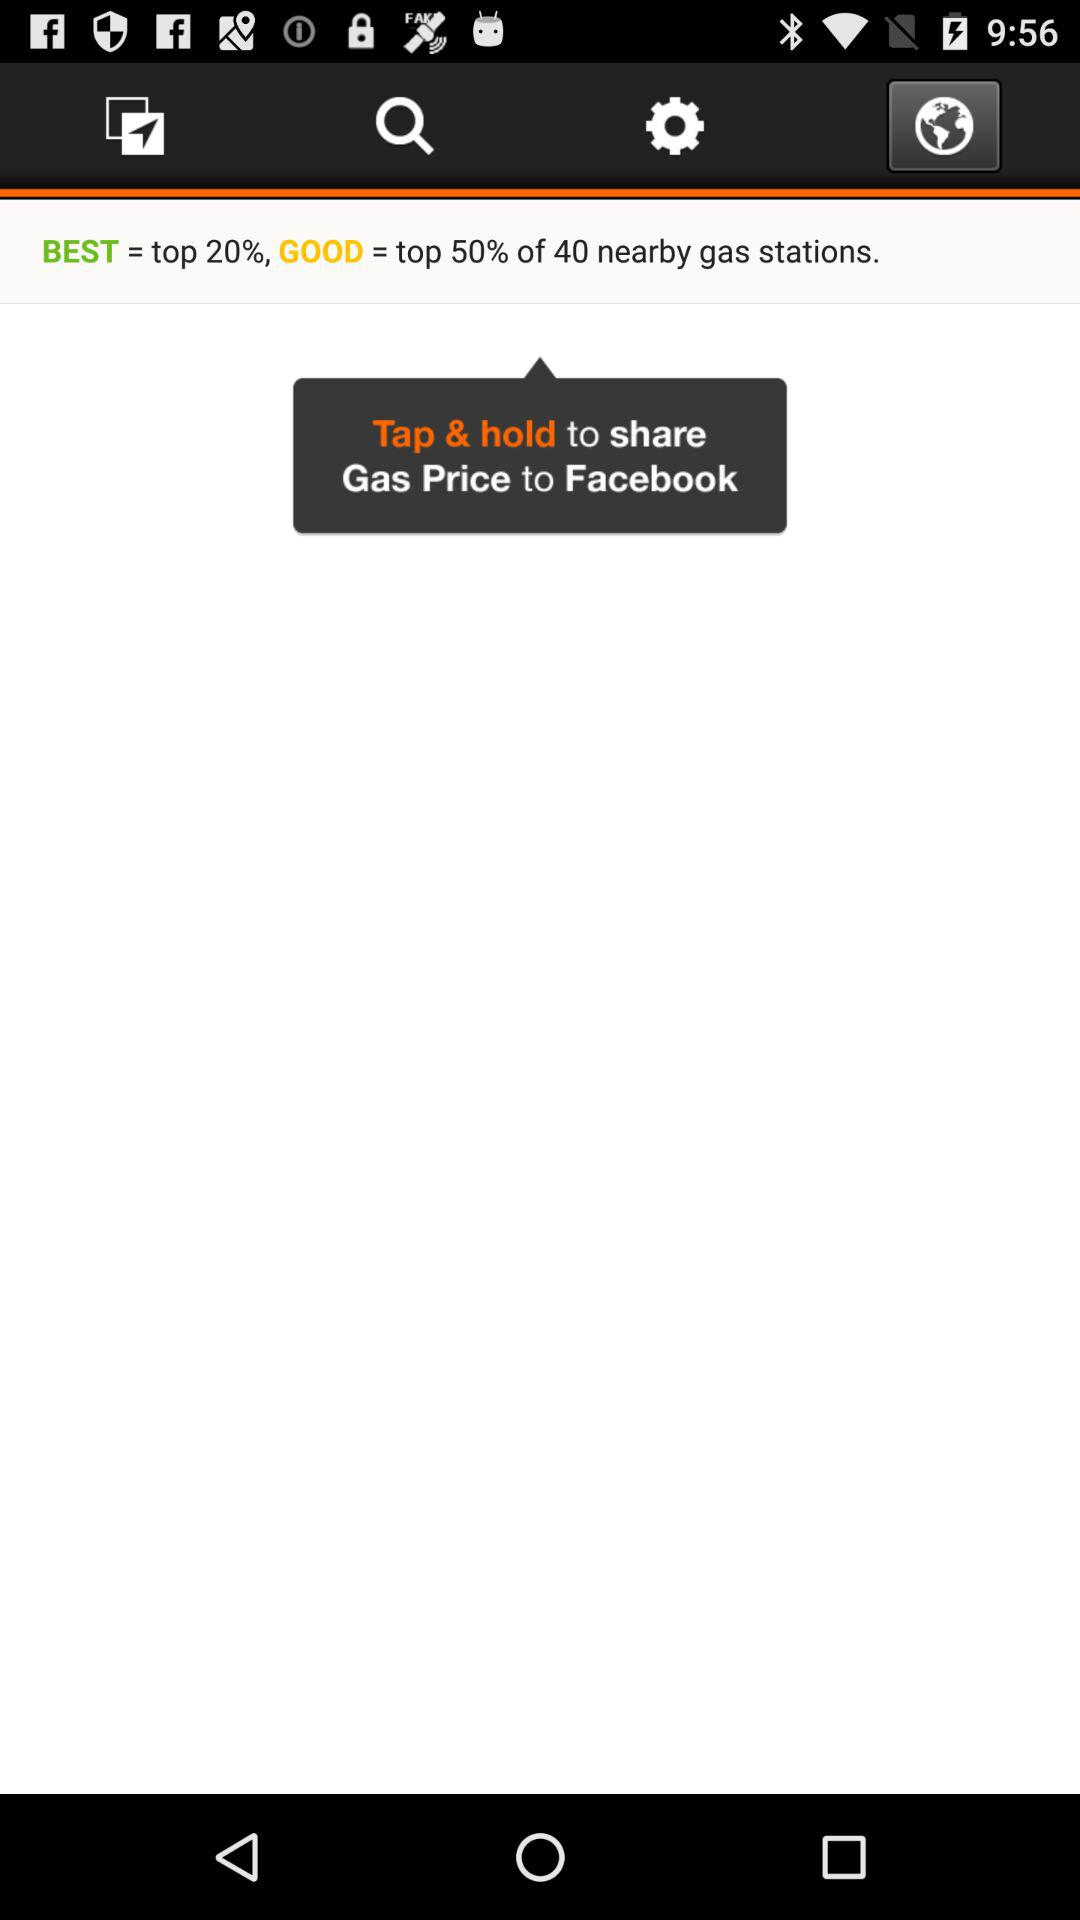How many percent of the gas stations are in the good category?
Answer the question using a single word or phrase. 50% 